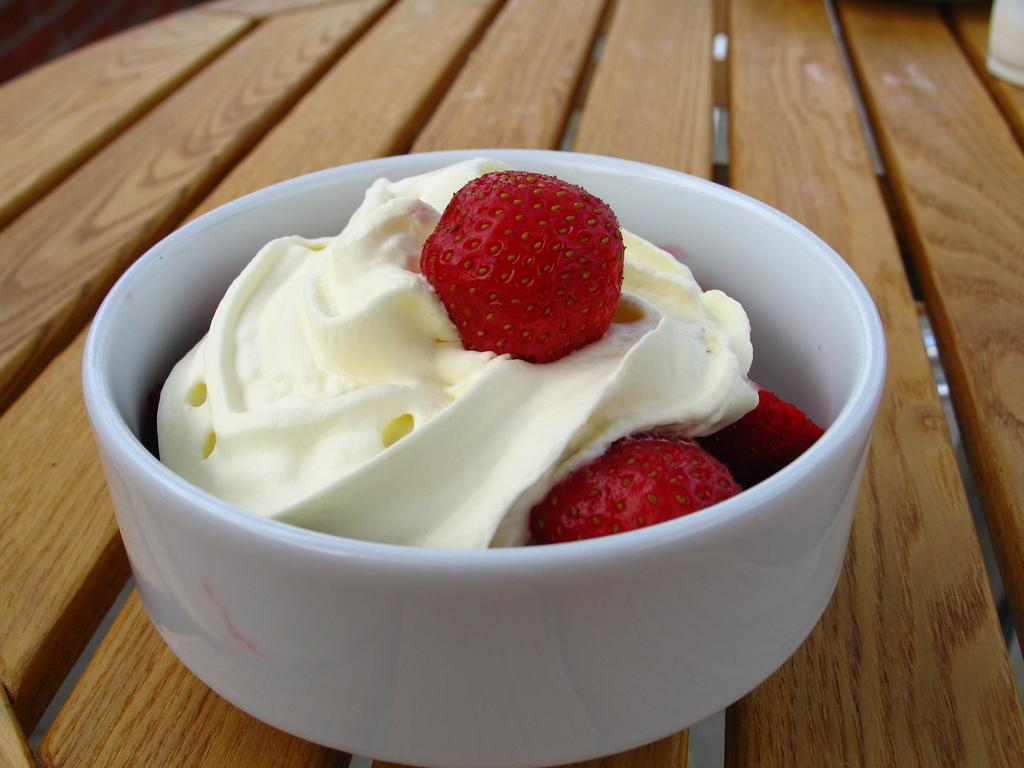What is in the cup that is visible in the image? The cup contains food items and cream. Where is the cup located in the image? The cup is placed on a wooden surface. How many pizzas is the daughter eating in the image? There is no daughter or pizzas present in the image. 